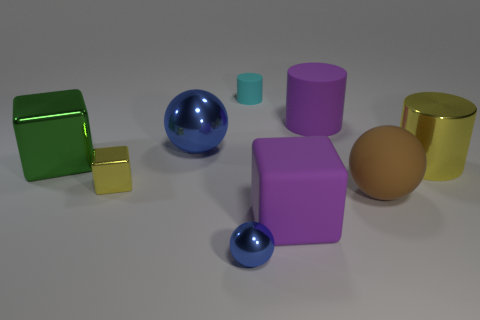Subtract all blue balls. How many were subtracted if there are1blue balls left? 1 Subtract 0 brown cubes. How many objects are left? 9 Subtract all cylinders. How many objects are left? 6 Subtract 3 spheres. How many spheres are left? 0 Subtract all green blocks. Subtract all yellow balls. How many blocks are left? 2 Subtract all blue spheres. How many yellow cubes are left? 1 Subtract all tiny metal things. Subtract all small blue things. How many objects are left? 6 Add 8 purple rubber cylinders. How many purple rubber cylinders are left? 9 Add 1 big spheres. How many big spheres exist? 3 Add 1 large cyan shiny cubes. How many objects exist? 10 